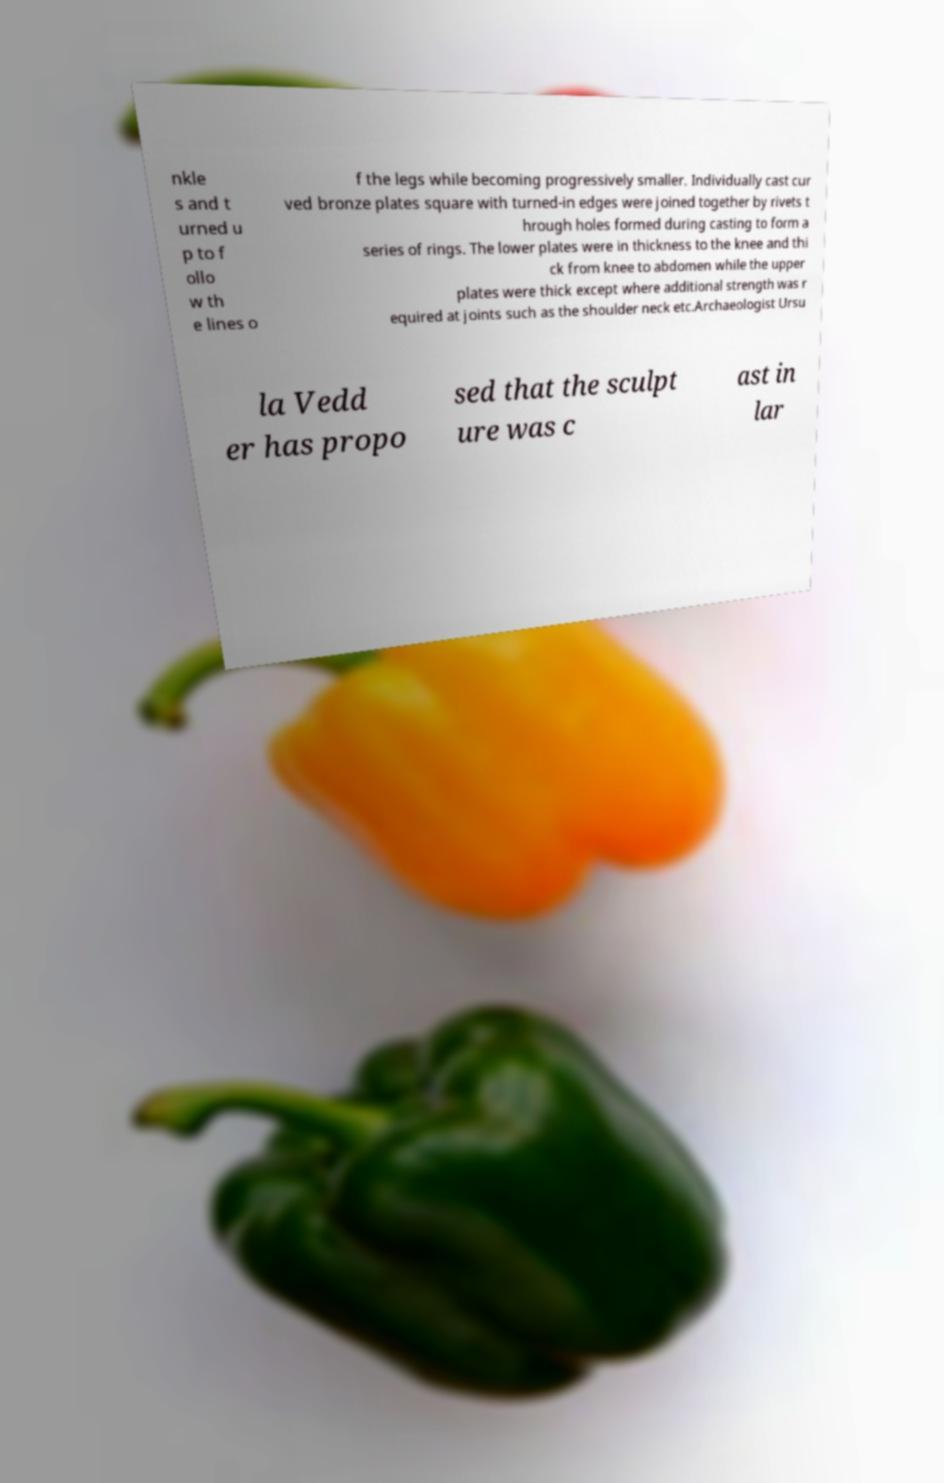Can you accurately transcribe the text from the provided image for me? nkle s and t urned u p to f ollo w th e lines o f the legs while becoming progressively smaller. Individually cast cur ved bronze plates square with turned-in edges were joined together by rivets t hrough holes formed during casting to form a series of rings. The lower plates were in thickness to the knee and thi ck from knee to abdomen while the upper plates were thick except where additional strength was r equired at joints such as the shoulder neck etc.Archaeologist Ursu la Vedd er has propo sed that the sculpt ure was c ast in lar 